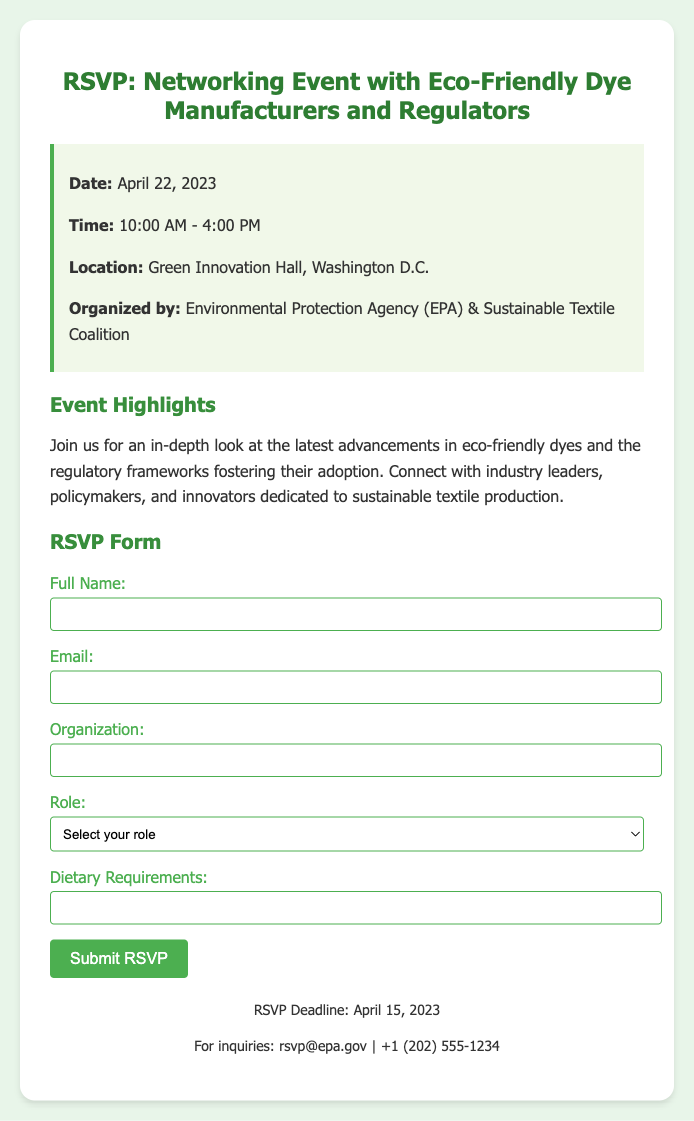What is the date of the event? The event is scheduled for April 22, 2023, as mentioned in the document.
Answer: April 22, 2023 What time does the event start? The starting time for the event is indicated as 10:00 AM, as per the event details.
Answer: 10:00 AM Where is the event taking place? The location of the event is specified as Green Innovation Hall, Washington D.C.
Answer: Green Innovation Hall, Washington D.C Who is organizing the event? The document mentions that the event is organized by the Environmental Protection Agency (EPA) and the Sustainable Textile Coalition.
Answer: Environmental Protection Agency (EPA) & Sustainable Textile Coalition What is the RSVP deadline? The RSVP deadline is stated clearly in the footer of the document as April 15, 2023.
Answer: April 15, 2023 What roles can attendees select in the RSVP form? The document lists four roles in the RSVP form: Government Official, Dye Manufacturer, Regulator, Other.
Answer: Government Official, Dye Manufacturer, Regulator, Other What is the purpose of the event? The purpose of the event involves discussing eco-friendly dyes and regulatory frameworks, as explained in the highlights section.
Answer: Discuss advancements in eco-friendly dyes 